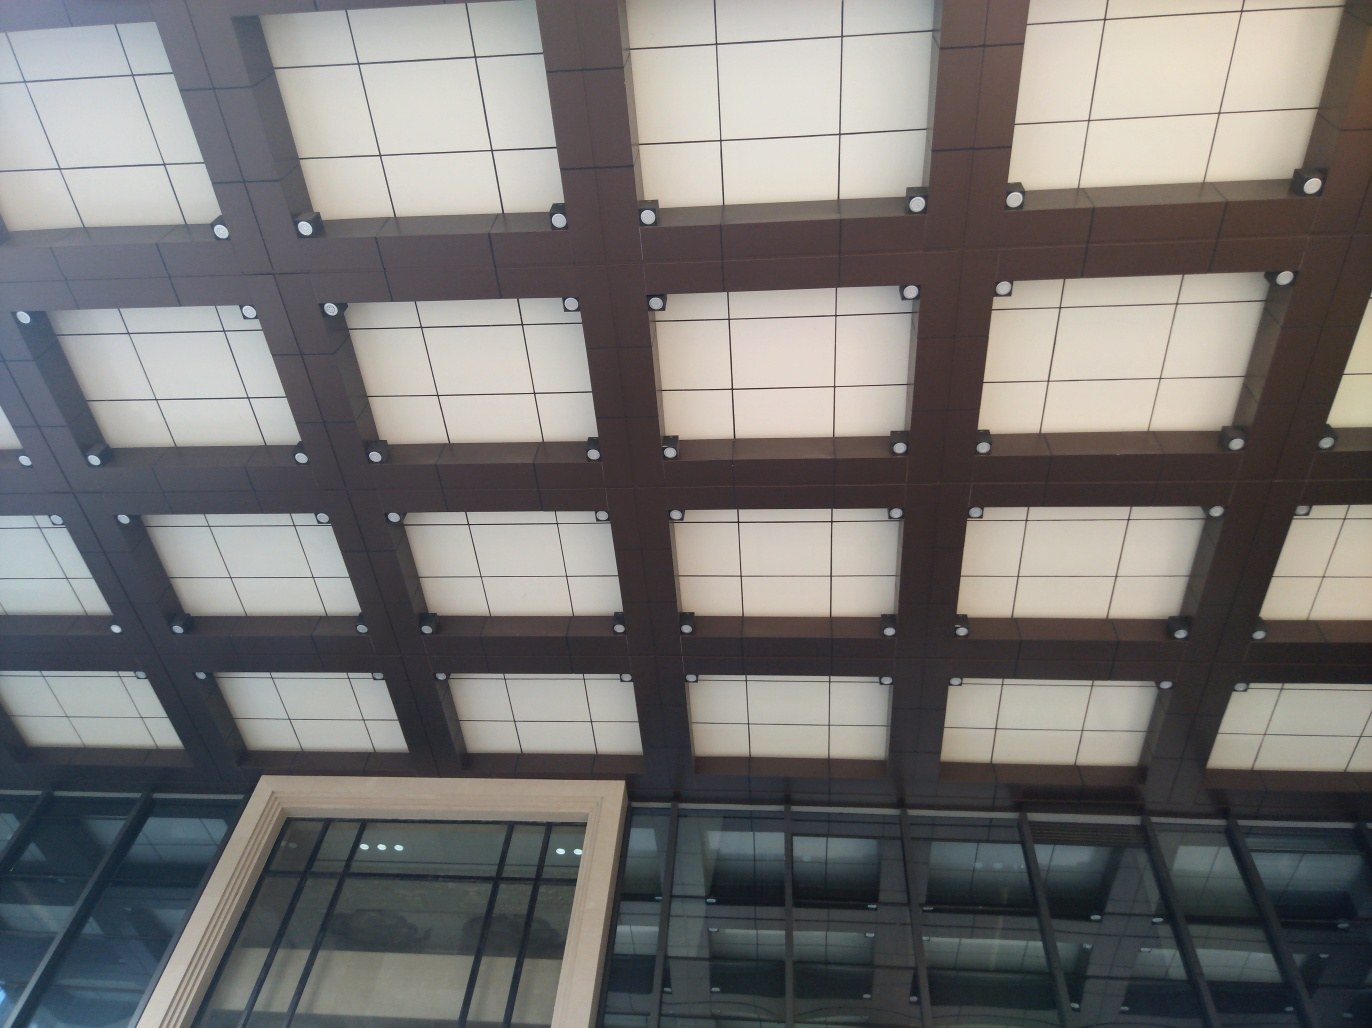How do the different shades of the panels affect the overall design? The alternating shades create a visual rhythm and depth, enhancing the three-dimensional feel of the space. This contrast between the panels can animate the surface, adding character and a dynamic quality to the overall design. 